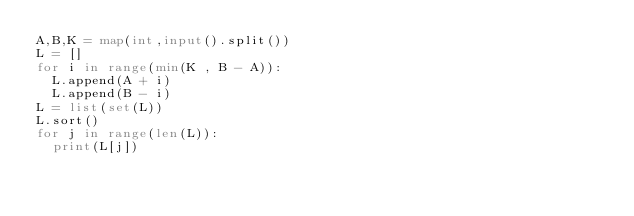<code> <loc_0><loc_0><loc_500><loc_500><_Python_>A,B,K = map(int,input().split())
L = []
for i in range(min(K , B - A)):
  L.append(A + i)
  L.append(B - i)
L = list(set(L))
L.sort()
for j in range(len(L)):
  print(L[j])
  </code> 